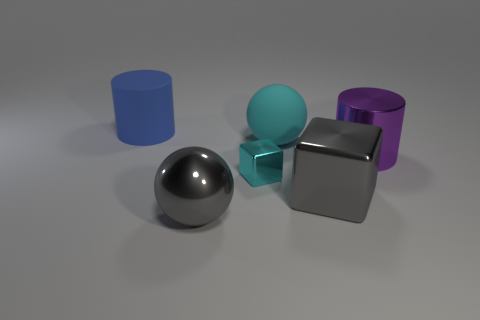There is a large blue thing; is its shape the same as the gray metallic thing on the right side of the big cyan matte ball?
Your answer should be compact. No. How big is the cyan sphere?
Your answer should be very brief. Large. Are there fewer cyan metallic cubes right of the big purple shiny cylinder than big metal things?
Provide a succinct answer. Yes. How many shiny balls have the same size as the gray metallic block?
Offer a very short reply. 1. The large thing that is the same color as the small object is what shape?
Make the answer very short. Sphere. Is the color of the big metallic object in front of the large gray shiny cube the same as the big cylinder behind the purple cylinder?
Ensure brevity in your answer.  No. There is a cyan matte object; how many big metallic cylinders are in front of it?
Your response must be concise. 1. What size is the thing that is the same color as the large metallic cube?
Give a very brief answer. Large. Is there another large blue object of the same shape as the big blue thing?
Provide a succinct answer. No. There is a block that is the same size as the purple shiny thing; what color is it?
Provide a short and direct response. Gray. 